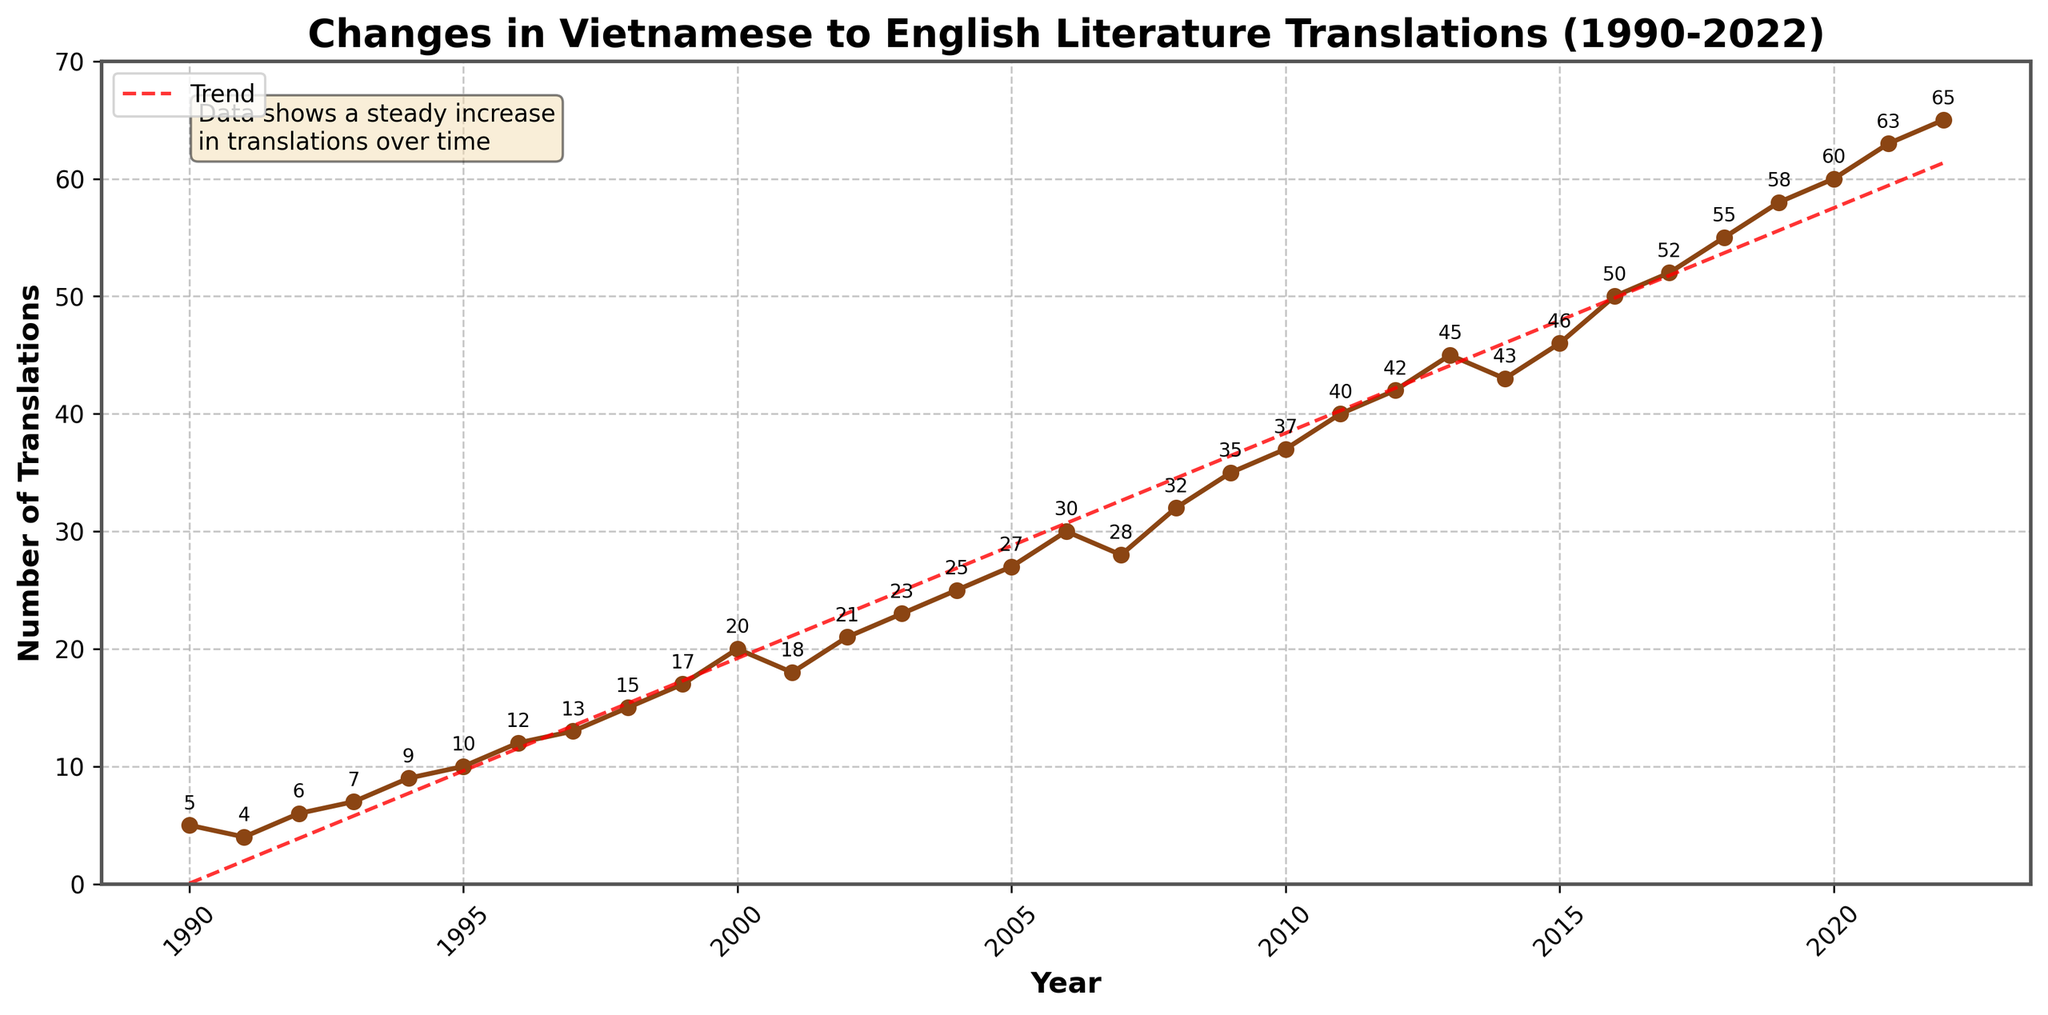What is the title of the figure? The title can be found at the top of the figure. It reads: 'Changes in Vietnamese to English Literature Translations (1990-2022)'.
Answer: Changes in Vietnamese to English Literature Translations (1990-2022) How many tick marks are there on the x-axis? The x-axis tick marks are visible along the bottom of the figure. They are labeled at intervals of five years, from 1990 to 2020.
Answer: 7 What is the minimum number of translations published in a year? The minimum number of translations can be identified by observing the lowest point in the vertical values (y-axis). This corresponds to the year 1991 with 4 translations.
Answer: 4 How many translations were published in the year 2005? You can find the value for the year 2005 by locating the data point on the plot and referring to the annotation next to it. It reads 27.
Answer: 27 Which year saw the highest number of translations, and what was that number? The highest point on the graph highlights the maximum number of translations, which is 65 in 2022.
Answer: 2022, 65 By how many translations did the number increase from 2000 to 2010? First, find the number of translations in 2000 (20) and in 2010 (37). Compute the difference: 37 - 20 = 17.
Answer: 17 What is the general trend of the translations from 1990 to 2022? The trend line (dashed red) illustrates a steady increase in the number of translations, indicating a positive trend over the years.
Answer: Increasing Is there any year where the number of translations decreased compared to the previous year? Observe the plot line for any downward dips. There is a decrease from 2000 to 2001 and from 2014 to 2015.
Answer: Yes What was the average number of translations per year from 1990 to 2022? Calculate the average by summing up all the translation values from 1990 to 2022 and dividing by the number of years (33). Sum = 960, so average = 960/33 ≈ 29.09.
Answer: 29.09 How did the number of translations change from 2008 to 2009? Locate the points for 2008 (32 translations) and 2009 (35 translations). The change is: 35 - 32 = 3.
Answer: Increase by 3 